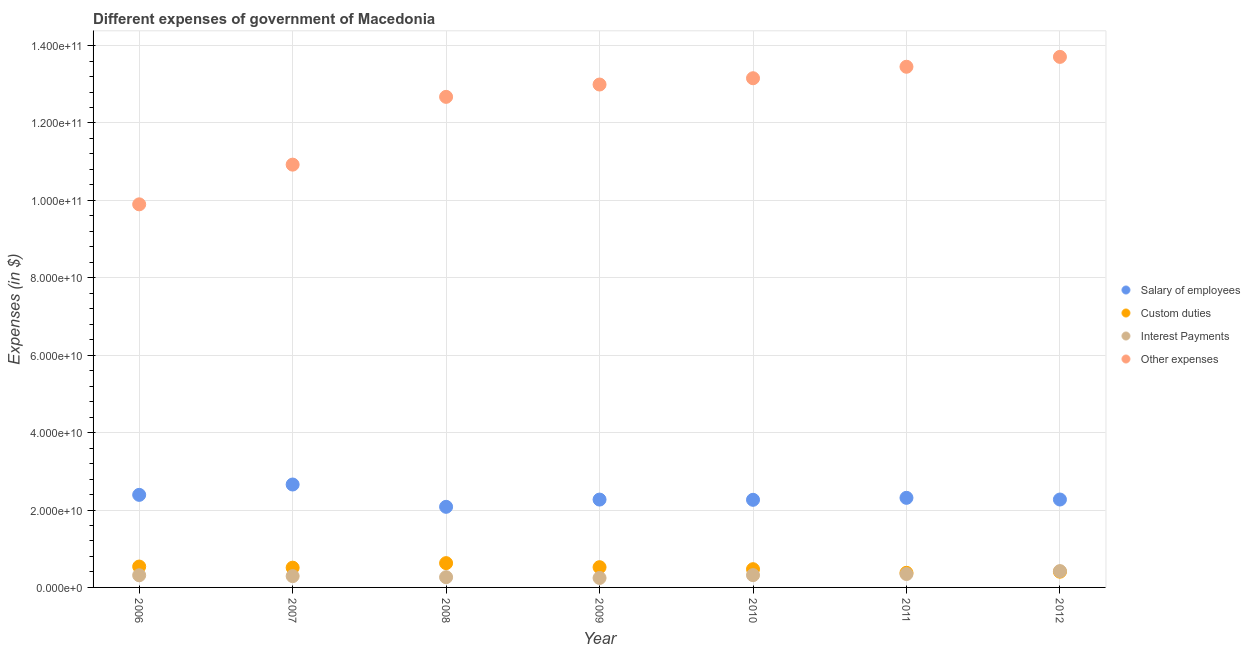How many different coloured dotlines are there?
Offer a terse response. 4. What is the amount spent on interest payments in 2008?
Your answer should be very brief. 2.65e+09. Across all years, what is the maximum amount spent on custom duties?
Your answer should be compact. 6.28e+09. Across all years, what is the minimum amount spent on custom duties?
Your response must be concise. 3.78e+09. What is the total amount spent on custom duties in the graph?
Make the answer very short. 3.46e+1. What is the difference between the amount spent on interest payments in 2010 and that in 2012?
Your answer should be compact. -1.04e+09. What is the difference between the amount spent on custom duties in 2007 and the amount spent on salary of employees in 2009?
Provide a short and direct response. -1.76e+1. What is the average amount spent on salary of employees per year?
Offer a terse response. 2.32e+1. In the year 2012, what is the difference between the amount spent on custom duties and amount spent on salary of employees?
Your answer should be compact. -1.86e+1. What is the ratio of the amount spent on interest payments in 2009 to that in 2012?
Ensure brevity in your answer.  0.58. Is the amount spent on interest payments in 2007 less than that in 2010?
Offer a terse response. Yes. Is the difference between the amount spent on custom duties in 2007 and 2011 greater than the difference between the amount spent on interest payments in 2007 and 2011?
Your answer should be very brief. Yes. What is the difference between the highest and the second highest amount spent on other expenses?
Offer a terse response. 2.55e+09. What is the difference between the highest and the lowest amount spent on salary of employees?
Offer a very short reply. 5.76e+09. Is it the case that in every year, the sum of the amount spent on salary of employees and amount spent on custom duties is greater than the amount spent on interest payments?
Make the answer very short. Yes. Is the amount spent on interest payments strictly greater than the amount spent on other expenses over the years?
Your response must be concise. No. How many years are there in the graph?
Ensure brevity in your answer.  7. Does the graph contain any zero values?
Your answer should be very brief. No. What is the title of the graph?
Offer a terse response. Different expenses of government of Macedonia. Does "Social Awareness" appear as one of the legend labels in the graph?
Your answer should be very brief. No. What is the label or title of the Y-axis?
Offer a terse response. Expenses (in $). What is the Expenses (in $) of Salary of employees in 2006?
Offer a very short reply. 2.39e+1. What is the Expenses (in $) of Custom duties in 2006?
Keep it short and to the point. 5.40e+09. What is the Expenses (in $) in Interest Payments in 2006?
Keep it short and to the point. 3.14e+09. What is the Expenses (in $) in Other expenses in 2006?
Offer a very short reply. 9.90e+1. What is the Expenses (in $) in Salary of employees in 2007?
Give a very brief answer. 2.66e+1. What is the Expenses (in $) of Custom duties in 2007?
Give a very brief answer. 5.10e+09. What is the Expenses (in $) of Interest Payments in 2007?
Ensure brevity in your answer.  2.92e+09. What is the Expenses (in $) in Other expenses in 2007?
Provide a succinct answer. 1.09e+11. What is the Expenses (in $) in Salary of employees in 2008?
Offer a very short reply. 2.08e+1. What is the Expenses (in $) of Custom duties in 2008?
Keep it short and to the point. 6.28e+09. What is the Expenses (in $) in Interest Payments in 2008?
Offer a terse response. 2.65e+09. What is the Expenses (in $) of Other expenses in 2008?
Provide a short and direct response. 1.27e+11. What is the Expenses (in $) of Salary of employees in 2009?
Offer a very short reply. 2.27e+1. What is the Expenses (in $) of Custom duties in 2009?
Ensure brevity in your answer.  5.23e+09. What is the Expenses (in $) in Interest Payments in 2009?
Provide a short and direct response. 2.44e+09. What is the Expenses (in $) of Other expenses in 2009?
Your answer should be compact. 1.30e+11. What is the Expenses (in $) of Salary of employees in 2010?
Your answer should be very brief. 2.26e+1. What is the Expenses (in $) in Custom duties in 2010?
Provide a short and direct response. 4.71e+09. What is the Expenses (in $) of Interest Payments in 2010?
Offer a very short reply. 3.17e+09. What is the Expenses (in $) of Other expenses in 2010?
Your answer should be compact. 1.32e+11. What is the Expenses (in $) in Salary of employees in 2011?
Ensure brevity in your answer.  2.31e+1. What is the Expenses (in $) in Custom duties in 2011?
Give a very brief answer. 3.78e+09. What is the Expenses (in $) in Interest Payments in 2011?
Your answer should be very brief. 3.47e+09. What is the Expenses (in $) of Other expenses in 2011?
Your answer should be very brief. 1.35e+11. What is the Expenses (in $) of Salary of employees in 2012?
Your response must be concise. 2.27e+1. What is the Expenses (in $) of Custom duties in 2012?
Your answer should be compact. 4.07e+09. What is the Expenses (in $) in Interest Payments in 2012?
Make the answer very short. 4.22e+09. What is the Expenses (in $) in Other expenses in 2012?
Give a very brief answer. 1.37e+11. Across all years, what is the maximum Expenses (in $) of Salary of employees?
Offer a terse response. 2.66e+1. Across all years, what is the maximum Expenses (in $) of Custom duties?
Keep it short and to the point. 6.28e+09. Across all years, what is the maximum Expenses (in $) of Interest Payments?
Ensure brevity in your answer.  4.22e+09. Across all years, what is the maximum Expenses (in $) in Other expenses?
Give a very brief answer. 1.37e+11. Across all years, what is the minimum Expenses (in $) in Salary of employees?
Provide a succinct answer. 2.08e+1. Across all years, what is the minimum Expenses (in $) of Custom duties?
Give a very brief answer. 3.78e+09. Across all years, what is the minimum Expenses (in $) in Interest Payments?
Your answer should be very brief. 2.44e+09. Across all years, what is the minimum Expenses (in $) in Other expenses?
Keep it short and to the point. 9.90e+1. What is the total Expenses (in $) of Salary of employees in the graph?
Provide a short and direct response. 1.63e+11. What is the total Expenses (in $) of Custom duties in the graph?
Provide a succinct answer. 3.46e+1. What is the total Expenses (in $) in Interest Payments in the graph?
Keep it short and to the point. 2.20e+1. What is the total Expenses (in $) of Other expenses in the graph?
Provide a short and direct response. 8.68e+11. What is the difference between the Expenses (in $) of Salary of employees in 2006 and that in 2007?
Offer a terse response. -2.67e+09. What is the difference between the Expenses (in $) in Custom duties in 2006 and that in 2007?
Ensure brevity in your answer.  2.94e+08. What is the difference between the Expenses (in $) in Interest Payments in 2006 and that in 2007?
Your answer should be compact. 2.22e+08. What is the difference between the Expenses (in $) of Other expenses in 2006 and that in 2007?
Your response must be concise. -1.03e+1. What is the difference between the Expenses (in $) in Salary of employees in 2006 and that in 2008?
Provide a short and direct response. 3.09e+09. What is the difference between the Expenses (in $) in Custom duties in 2006 and that in 2008?
Your response must be concise. -8.78e+08. What is the difference between the Expenses (in $) in Interest Payments in 2006 and that in 2008?
Offer a very short reply. 4.94e+08. What is the difference between the Expenses (in $) of Other expenses in 2006 and that in 2008?
Offer a very short reply. -2.78e+1. What is the difference between the Expenses (in $) of Salary of employees in 2006 and that in 2009?
Provide a succinct answer. 1.22e+09. What is the difference between the Expenses (in $) of Custom duties in 2006 and that in 2009?
Offer a terse response. 1.68e+08. What is the difference between the Expenses (in $) in Interest Payments in 2006 and that in 2009?
Make the answer very short. 6.95e+08. What is the difference between the Expenses (in $) in Other expenses in 2006 and that in 2009?
Provide a short and direct response. -3.10e+1. What is the difference between the Expenses (in $) of Salary of employees in 2006 and that in 2010?
Make the answer very short. 1.28e+09. What is the difference between the Expenses (in $) in Custom duties in 2006 and that in 2010?
Give a very brief answer. 6.85e+08. What is the difference between the Expenses (in $) of Interest Payments in 2006 and that in 2010?
Offer a terse response. -3.39e+07. What is the difference between the Expenses (in $) of Other expenses in 2006 and that in 2010?
Provide a succinct answer. -3.26e+1. What is the difference between the Expenses (in $) in Salary of employees in 2006 and that in 2011?
Keep it short and to the point. 7.71e+08. What is the difference between the Expenses (in $) in Custom duties in 2006 and that in 2011?
Provide a succinct answer. 1.62e+09. What is the difference between the Expenses (in $) of Interest Payments in 2006 and that in 2011?
Provide a succinct answer. -3.31e+08. What is the difference between the Expenses (in $) in Other expenses in 2006 and that in 2011?
Your answer should be very brief. -3.55e+1. What is the difference between the Expenses (in $) of Salary of employees in 2006 and that in 2012?
Ensure brevity in your answer.  1.20e+09. What is the difference between the Expenses (in $) of Custom duties in 2006 and that in 2012?
Your response must be concise. 1.33e+09. What is the difference between the Expenses (in $) of Interest Payments in 2006 and that in 2012?
Offer a very short reply. -1.08e+09. What is the difference between the Expenses (in $) of Other expenses in 2006 and that in 2012?
Your answer should be compact. -3.81e+1. What is the difference between the Expenses (in $) in Salary of employees in 2007 and that in 2008?
Your response must be concise. 5.76e+09. What is the difference between the Expenses (in $) in Custom duties in 2007 and that in 2008?
Offer a very short reply. -1.17e+09. What is the difference between the Expenses (in $) in Interest Payments in 2007 and that in 2008?
Your answer should be very brief. 2.72e+08. What is the difference between the Expenses (in $) of Other expenses in 2007 and that in 2008?
Ensure brevity in your answer.  -1.75e+1. What is the difference between the Expenses (in $) in Salary of employees in 2007 and that in 2009?
Make the answer very short. 3.89e+09. What is the difference between the Expenses (in $) of Custom duties in 2007 and that in 2009?
Provide a succinct answer. -1.26e+08. What is the difference between the Expenses (in $) in Interest Payments in 2007 and that in 2009?
Provide a short and direct response. 4.73e+08. What is the difference between the Expenses (in $) in Other expenses in 2007 and that in 2009?
Offer a terse response. -2.07e+1. What is the difference between the Expenses (in $) of Salary of employees in 2007 and that in 2010?
Provide a succinct answer. 3.95e+09. What is the difference between the Expenses (in $) of Custom duties in 2007 and that in 2010?
Make the answer very short. 3.91e+08. What is the difference between the Expenses (in $) of Interest Payments in 2007 and that in 2010?
Make the answer very short. -2.56e+08. What is the difference between the Expenses (in $) of Other expenses in 2007 and that in 2010?
Keep it short and to the point. -2.23e+1. What is the difference between the Expenses (in $) of Salary of employees in 2007 and that in 2011?
Provide a succinct answer. 3.44e+09. What is the difference between the Expenses (in $) in Custom duties in 2007 and that in 2011?
Your answer should be compact. 1.32e+09. What is the difference between the Expenses (in $) of Interest Payments in 2007 and that in 2011?
Make the answer very short. -5.53e+08. What is the difference between the Expenses (in $) of Other expenses in 2007 and that in 2011?
Give a very brief answer. -2.53e+1. What is the difference between the Expenses (in $) of Salary of employees in 2007 and that in 2012?
Ensure brevity in your answer.  3.88e+09. What is the difference between the Expenses (in $) in Custom duties in 2007 and that in 2012?
Your response must be concise. 1.04e+09. What is the difference between the Expenses (in $) in Interest Payments in 2007 and that in 2012?
Offer a terse response. -1.30e+09. What is the difference between the Expenses (in $) in Other expenses in 2007 and that in 2012?
Make the answer very short. -2.78e+1. What is the difference between the Expenses (in $) in Salary of employees in 2008 and that in 2009?
Your answer should be compact. -1.87e+09. What is the difference between the Expenses (in $) of Custom duties in 2008 and that in 2009?
Ensure brevity in your answer.  1.05e+09. What is the difference between the Expenses (in $) of Interest Payments in 2008 and that in 2009?
Offer a terse response. 2.01e+08. What is the difference between the Expenses (in $) of Other expenses in 2008 and that in 2009?
Keep it short and to the point. -3.19e+09. What is the difference between the Expenses (in $) of Salary of employees in 2008 and that in 2010?
Make the answer very short. -1.81e+09. What is the difference between the Expenses (in $) in Custom duties in 2008 and that in 2010?
Keep it short and to the point. 1.56e+09. What is the difference between the Expenses (in $) of Interest Payments in 2008 and that in 2010?
Make the answer very short. -5.28e+08. What is the difference between the Expenses (in $) of Other expenses in 2008 and that in 2010?
Ensure brevity in your answer.  -4.81e+09. What is the difference between the Expenses (in $) of Salary of employees in 2008 and that in 2011?
Keep it short and to the point. -2.32e+09. What is the difference between the Expenses (in $) of Custom duties in 2008 and that in 2011?
Give a very brief answer. 2.50e+09. What is the difference between the Expenses (in $) in Interest Payments in 2008 and that in 2011?
Offer a very short reply. -8.25e+08. What is the difference between the Expenses (in $) in Other expenses in 2008 and that in 2011?
Provide a succinct answer. -7.78e+09. What is the difference between the Expenses (in $) in Salary of employees in 2008 and that in 2012?
Ensure brevity in your answer.  -1.89e+09. What is the difference between the Expenses (in $) of Custom duties in 2008 and that in 2012?
Provide a short and direct response. 2.21e+09. What is the difference between the Expenses (in $) of Interest Payments in 2008 and that in 2012?
Your answer should be very brief. -1.57e+09. What is the difference between the Expenses (in $) in Other expenses in 2008 and that in 2012?
Your response must be concise. -1.03e+1. What is the difference between the Expenses (in $) in Salary of employees in 2009 and that in 2010?
Provide a short and direct response. 6.10e+07. What is the difference between the Expenses (in $) in Custom duties in 2009 and that in 2010?
Your response must be concise. 5.17e+08. What is the difference between the Expenses (in $) of Interest Payments in 2009 and that in 2010?
Keep it short and to the point. -7.29e+08. What is the difference between the Expenses (in $) in Other expenses in 2009 and that in 2010?
Ensure brevity in your answer.  -1.62e+09. What is the difference between the Expenses (in $) in Salary of employees in 2009 and that in 2011?
Make the answer very short. -4.48e+08. What is the difference between the Expenses (in $) in Custom duties in 2009 and that in 2011?
Ensure brevity in your answer.  1.45e+09. What is the difference between the Expenses (in $) in Interest Payments in 2009 and that in 2011?
Provide a succinct answer. -1.03e+09. What is the difference between the Expenses (in $) in Other expenses in 2009 and that in 2011?
Your answer should be very brief. -4.59e+09. What is the difference between the Expenses (in $) of Salary of employees in 2009 and that in 2012?
Provide a succinct answer. -1.50e+07. What is the difference between the Expenses (in $) of Custom duties in 2009 and that in 2012?
Keep it short and to the point. 1.16e+09. What is the difference between the Expenses (in $) of Interest Payments in 2009 and that in 2012?
Your response must be concise. -1.77e+09. What is the difference between the Expenses (in $) of Other expenses in 2009 and that in 2012?
Your answer should be very brief. -7.14e+09. What is the difference between the Expenses (in $) of Salary of employees in 2010 and that in 2011?
Offer a terse response. -5.09e+08. What is the difference between the Expenses (in $) in Custom duties in 2010 and that in 2011?
Ensure brevity in your answer.  9.33e+08. What is the difference between the Expenses (in $) of Interest Payments in 2010 and that in 2011?
Offer a very short reply. -2.97e+08. What is the difference between the Expenses (in $) in Other expenses in 2010 and that in 2011?
Keep it short and to the point. -2.96e+09. What is the difference between the Expenses (in $) of Salary of employees in 2010 and that in 2012?
Your answer should be very brief. -7.60e+07. What is the difference between the Expenses (in $) in Custom duties in 2010 and that in 2012?
Your answer should be very brief. 6.45e+08. What is the difference between the Expenses (in $) of Interest Payments in 2010 and that in 2012?
Provide a succinct answer. -1.04e+09. What is the difference between the Expenses (in $) in Other expenses in 2010 and that in 2012?
Ensure brevity in your answer.  -5.52e+09. What is the difference between the Expenses (in $) of Salary of employees in 2011 and that in 2012?
Keep it short and to the point. 4.33e+08. What is the difference between the Expenses (in $) of Custom duties in 2011 and that in 2012?
Offer a terse response. -2.88e+08. What is the difference between the Expenses (in $) in Interest Payments in 2011 and that in 2012?
Your answer should be compact. -7.45e+08. What is the difference between the Expenses (in $) in Other expenses in 2011 and that in 2012?
Offer a very short reply. -2.55e+09. What is the difference between the Expenses (in $) in Salary of employees in 2006 and the Expenses (in $) in Custom duties in 2007?
Make the answer very short. 1.88e+1. What is the difference between the Expenses (in $) in Salary of employees in 2006 and the Expenses (in $) in Interest Payments in 2007?
Give a very brief answer. 2.10e+1. What is the difference between the Expenses (in $) in Salary of employees in 2006 and the Expenses (in $) in Other expenses in 2007?
Offer a terse response. -8.53e+1. What is the difference between the Expenses (in $) of Custom duties in 2006 and the Expenses (in $) of Interest Payments in 2007?
Offer a very short reply. 2.48e+09. What is the difference between the Expenses (in $) of Custom duties in 2006 and the Expenses (in $) of Other expenses in 2007?
Offer a very short reply. -1.04e+11. What is the difference between the Expenses (in $) in Interest Payments in 2006 and the Expenses (in $) in Other expenses in 2007?
Provide a succinct answer. -1.06e+11. What is the difference between the Expenses (in $) of Salary of employees in 2006 and the Expenses (in $) of Custom duties in 2008?
Your response must be concise. 1.76e+1. What is the difference between the Expenses (in $) of Salary of employees in 2006 and the Expenses (in $) of Interest Payments in 2008?
Offer a terse response. 2.13e+1. What is the difference between the Expenses (in $) of Salary of employees in 2006 and the Expenses (in $) of Other expenses in 2008?
Your response must be concise. -1.03e+11. What is the difference between the Expenses (in $) of Custom duties in 2006 and the Expenses (in $) of Interest Payments in 2008?
Offer a terse response. 2.75e+09. What is the difference between the Expenses (in $) of Custom duties in 2006 and the Expenses (in $) of Other expenses in 2008?
Ensure brevity in your answer.  -1.21e+11. What is the difference between the Expenses (in $) in Interest Payments in 2006 and the Expenses (in $) in Other expenses in 2008?
Provide a succinct answer. -1.24e+11. What is the difference between the Expenses (in $) in Salary of employees in 2006 and the Expenses (in $) in Custom duties in 2009?
Offer a terse response. 1.87e+1. What is the difference between the Expenses (in $) of Salary of employees in 2006 and the Expenses (in $) of Interest Payments in 2009?
Your answer should be very brief. 2.15e+1. What is the difference between the Expenses (in $) of Salary of employees in 2006 and the Expenses (in $) of Other expenses in 2009?
Keep it short and to the point. -1.06e+11. What is the difference between the Expenses (in $) in Custom duties in 2006 and the Expenses (in $) in Interest Payments in 2009?
Provide a short and direct response. 2.95e+09. What is the difference between the Expenses (in $) of Custom duties in 2006 and the Expenses (in $) of Other expenses in 2009?
Provide a succinct answer. -1.25e+11. What is the difference between the Expenses (in $) of Interest Payments in 2006 and the Expenses (in $) of Other expenses in 2009?
Provide a short and direct response. -1.27e+11. What is the difference between the Expenses (in $) in Salary of employees in 2006 and the Expenses (in $) in Custom duties in 2010?
Keep it short and to the point. 1.92e+1. What is the difference between the Expenses (in $) in Salary of employees in 2006 and the Expenses (in $) in Interest Payments in 2010?
Ensure brevity in your answer.  2.07e+1. What is the difference between the Expenses (in $) in Salary of employees in 2006 and the Expenses (in $) in Other expenses in 2010?
Offer a very short reply. -1.08e+11. What is the difference between the Expenses (in $) in Custom duties in 2006 and the Expenses (in $) in Interest Payments in 2010?
Your answer should be very brief. 2.22e+09. What is the difference between the Expenses (in $) of Custom duties in 2006 and the Expenses (in $) of Other expenses in 2010?
Provide a short and direct response. -1.26e+11. What is the difference between the Expenses (in $) of Interest Payments in 2006 and the Expenses (in $) of Other expenses in 2010?
Ensure brevity in your answer.  -1.28e+11. What is the difference between the Expenses (in $) in Salary of employees in 2006 and the Expenses (in $) in Custom duties in 2011?
Give a very brief answer. 2.01e+1. What is the difference between the Expenses (in $) of Salary of employees in 2006 and the Expenses (in $) of Interest Payments in 2011?
Provide a succinct answer. 2.04e+1. What is the difference between the Expenses (in $) of Salary of employees in 2006 and the Expenses (in $) of Other expenses in 2011?
Keep it short and to the point. -1.11e+11. What is the difference between the Expenses (in $) in Custom duties in 2006 and the Expenses (in $) in Interest Payments in 2011?
Keep it short and to the point. 1.93e+09. What is the difference between the Expenses (in $) in Custom duties in 2006 and the Expenses (in $) in Other expenses in 2011?
Ensure brevity in your answer.  -1.29e+11. What is the difference between the Expenses (in $) of Interest Payments in 2006 and the Expenses (in $) of Other expenses in 2011?
Offer a terse response. -1.31e+11. What is the difference between the Expenses (in $) in Salary of employees in 2006 and the Expenses (in $) in Custom duties in 2012?
Your response must be concise. 1.99e+1. What is the difference between the Expenses (in $) of Salary of employees in 2006 and the Expenses (in $) of Interest Payments in 2012?
Offer a terse response. 1.97e+1. What is the difference between the Expenses (in $) in Salary of employees in 2006 and the Expenses (in $) in Other expenses in 2012?
Your answer should be compact. -1.13e+11. What is the difference between the Expenses (in $) in Custom duties in 2006 and the Expenses (in $) in Interest Payments in 2012?
Your answer should be very brief. 1.18e+09. What is the difference between the Expenses (in $) in Custom duties in 2006 and the Expenses (in $) in Other expenses in 2012?
Your answer should be very brief. -1.32e+11. What is the difference between the Expenses (in $) of Interest Payments in 2006 and the Expenses (in $) of Other expenses in 2012?
Offer a very short reply. -1.34e+11. What is the difference between the Expenses (in $) of Salary of employees in 2007 and the Expenses (in $) of Custom duties in 2008?
Offer a terse response. 2.03e+1. What is the difference between the Expenses (in $) of Salary of employees in 2007 and the Expenses (in $) of Interest Payments in 2008?
Provide a short and direct response. 2.39e+1. What is the difference between the Expenses (in $) in Salary of employees in 2007 and the Expenses (in $) in Other expenses in 2008?
Keep it short and to the point. -1.00e+11. What is the difference between the Expenses (in $) of Custom duties in 2007 and the Expenses (in $) of Interest Payments in 2008?
Provide a succinct answer. 2.46e+09. What is the difference between the Expenses (in $) in Custom duties in 2007 and the Expenses (in $) in Other expenses in 2008?
Your answer should be compact. -1.22e+11. What is the difference between the Expenses (in $) in Interest Payments in 2007 and the Expenses (in $) in Other expenses in 2008?
Give a very brief answer. -1.24e+11. What is the difference between the Expenses (in $) of Salary of employees in 2007 and the Expenses (in $) of Custom duties in 2009?
Provide a succinct answer. 2.14e+1. What is the difference between the Expenses (in $) in Salary of employees in 2007 and the Expenses (in $) in Interest Payments in 2009?
Provide a short and direct response. 2.41e+1. What is the difference between the Expenses (in $) of Salary of employees in 2007 and the Expenses (in $) of Other expenses in 2009?
Give a very brief answer. -1.03e+11. What is the difference between the Expenses (in $) of Custom duties in 2007 and the Expenses (in $) of Interest Payments in 2009?
Make the answer very short. 2.66e+09. What is the difference between the Expenses (in $) in Custom duties in 2007 and the Expenses (in $) in Other expenses in 2009?
Ensure brevity in your answer.  -1.25e+11. What is the difference between the Expenses (in $) of Interest Payments in 2007 and the Expenses (in $) of Other expenses in 2009?
Your answer should be compact. -1.27e+11. What is the difference between the Expenses (in $) in Salary of employees in 2007 and the Expenses (in $) in Custom duties in 2010?
Your answer should be very brief. 2.19e+1. What is the difference between the Expenses (in $) of Salary of employees in 2007 and the Expenses (in $) of Interest Payments in 2010?
Offer a very short reply. 2.34e+1. What is the difference between the Expenses (in $) of Salary of employees in 2007 and the Expenses (in $) of Other expenses in 2010?
Your answer should be very brief. -1.05e+11. What is the difference between the Expenses (in $) of Custom duties in 2007 and the Expenses (in $) of Interest Payments in 2010?
Your answer should be compact. 1.93e+09. What is the difference between the Expenses (in $) of Custom duties in 2007 and the Expenses (in $) of Other expenses in 2010?
Offer a terse response. -1.26e+11. What is the difference between the Expenses (in $) of Interest Payments in 2007 and the Expenses (in $) of Other expenses in 2010?
Your response must be concise. -1.29e+11. What is the difference between the Expenses (in $) of Salary of employees in 2007 and the Expenses (in $) of Custom duties in 2011?
Your answer should be compact. 2.28e+1. What is the difference between the Expenses (in $) in Salary of employees in 2007 and the Expenses (in $) in Interest Payments in 2011?
Ensure brevity in your answer.  2.31e+1. What is the difference between the Expenses (in $) of Salary of employees in 2007 and the Expenses (in $) of Other expenses in 2011?
Your response must be concise. -1.08e+11. What is the difference between the Expenses (in $) in Custom duties in 2007 and the Expenses (in $) in Interest Payments in 2011?
Make the answer very short. 1.63e+09. What is the difference between the Expenses (in $) of Custom duties in 2007 and the Expenses (in $) of Other expenses in 2011?
Offer a terse response. -1.29e+11. What is the difference between the Expenses (in $) in Interest Payments in 2007 and the Expenses (in $) in Other expenses in 2011?
Your response must be concise. -1.32e+11. What is the difference between the Expenses (in $) of Salary of employees in 2007 and the Expenses (in $) of Custom duties in 2012?
Offer a terse response. 2.25e+1. What is the difference between the Expenses (in $) in Salary of employees in 2007 and the Expenses (in $) in Interest Payments in 2012?
Keep it short and to the point. 2.24e+1. What is the difference between the Expenses (in $) in Salary of employees in 2007 and the Expenses (in $) in Other expenses in 2012?
Make the answer very short. -1.10e+11. What is the difference between the Expenses (in $) in Custom duties in 2007 and the Expenses (in $) in Interest Payments in 2012?
Ensure brevity in your answer.  8.87e+08. What is the difference between the Expenses (in $) of Custom duties in 2007 and the Expenses (in $) of Other expenses in 2012?
Ensure brevity in your answer.  -1.32e+11. What is the difference between the Expenses (in $) in Interest Payments in 2007 and the Expenses (in $) in Other expenses in 2012?
Provide a succinct answer. -1.34e+11. What is the difference between the Expenses (in $) in Salary of employees in 2008 and the Expenses (in $) in Custom duties in 2009?
Keep it short and to the point. 1.56e+1. What is the difference between the Expenses (in $) of Salary of employees in 2008 and the Expenses (in $) of Interest Payments in 2009?
Your answer should be compact. 1.84e+1. What is the difference between the Expenses (in $) in Salary of employees in 2008 and the Expenses (in $) in Other expenses in 2009?
Your answer should be compact. -1.09e+11. What is the difference between the Expenses (in $) in Custom duties in 2008 and the Expenses (in $) in Interest Payments in 2009?
Provide a succinct answer. 3.83e+09. What is the difference between the Expenses (in $) of Custom duties in 2008 and the Expenses (in $) of Other expenses in 2009?
Offer a terse response. -1.24e+11. What is the difference between the Expenses (in $) in Interest Payments in 2008 and the Expenses (in $) in Other expenses in 2009?
Offer a very short reply. -1.27e+11. What is the difference between the Expenses (in $) of Salary of employees in 2008 and the Expenses (in $) of Custom duties in 2010?
Provide a short and direct response. 1.61e+1. What is the difference between the Expenses (in $) in Salary of employees in 2008 and the Expenses (in $) in Interest Payments in 2010?
Your answer should be very brief. 1.77e+1. What is the difference between the Expenses (in $) of Salary of employees in 2008 and the Expenses (in $) of Other expenses in 2010?
Your answer should be compact. -1.11e+11. What is the difference between the Expenses (in $) in Custom duties in 2008 and the Expenses (in $) in Interest Payments in 2010?
Provide a succinct answer. 3.10e+09. What is the difference between the Expenses (in $) in Custom duties in 2008 and the Expenses (in $) in Other expenses in 2010?
Give a very brief answer. -1.25e+11. What is the difference between the Expenses (in $) in Interest Payments in 2008 and the Expenses (in $) in Other expenses in 2010?
Make the answer very short. -1.29e+11. What is the difference between the Expenses (in $) in Salary of employees in 2008 and the Expenses (in $) in Custom duties in 2011?
Ensure brevity in your answer.  1.70e+1. What is the difference between the Expenses (in $) of Salary of employees in 2008 and the Expenses (in $) of Interest Payments in 2011?
Keep it short and to the point. 1.74e+1. What is the difference between the Expenses (in $) of Salary of employees in 2008 and the Expenses (in $) of Other expenses in 2011?
Your response must be concise. -1.14e+11. What is the difference between the Expenses (in $) of Custom duties in 2008 and the Expenses (in $) of Interest Payments in 2011?
Your answer should be very brief. 2.80e+09. What is the difference between the Expenses (in $) of Custom duties in 2008 and the Expenses (in $) of Other expenses in 2011?
Offer a very short reply. -1.28e+11. What is the difference between the Expenses (in $) in Interest Payments in 2008 and the Expenses (in $) in Other expenses in 2011?
Make the answer very short. -1.32e+11. What is the difference between the Expenses (in $) of Salary of employees in 2008 and the Expenses (in $) of Custom duties in 2012?
Keep it short and to the point. 1.68e+1. What is the difference between the Expenses (in $) of Salary of employees in 2008 and the Expenses (in $) of Interest Payments in 2012?
Provide a short and direct response. 1.66e+1. What is the difference between the Expenses (in $) in Salary of employees in 2008 and the Expenses (in $) in Other expenses in 2012?
Ensure brevity in your answer.  -1.16e+11. What is the difference between the Expenses (in $) in Custom duties in 2008 and the Expenses (in $) in Interest Payments in 2012?
Offer a very short reply. 2.06e+09. What is the difference between the Expenses (in $) in Custom duties in 2008 and the Expenses (in $) in Other expenses in 2012?
Your response must be concise. -1.31e+11. What is the difference between the Expenses (in $) in Interest Payments in 2008 and the Expenses (in $) in Other expenses in 2012?
Offer a very short reply. -1.34e+11. What is the difference between the Expenses (in $) of Salary of employees in 2009 and the Expenses (in $) of Custom duties in 2010?
Provide a succinct answer. 1.80e+1. What is the difference between the Expenses (in $) of Salary of employees in 2009 and the Expenses (in $) of Interest Payments in 2010?
Your response must be concise. 1.95e+1. What is the difference between the Expenses (in $) of Salary of employees in 2009 and the Expenses (in $) of Other expenses in 2010?
Provide a short and direct response. -1.09e+11. What is the difference between the Expenses (in $) in Custom duties in 2009 and the Expenses (in $) in Interest Payments in 2010?
Make the answer very short. 2.06e+09. What is the difference between the Expenses (in $) of Custom duties in 2009 and the Expenses (in $) of Other expenses in 2010?
Make the answer very short. -1.26e+11. What is the difference between the Expenses (in $) of Interest Payments in 2009 and the Expenses (in $) of Other expenses in 2010?
Provide a short and direct response. -1.29e+11. What is the difference between the Expenses (in $) in Salary of employees in 2009 and the Expenses (in $) in Custom duties in 2011?
Your answer should be compact. 1.89e+1. What is the difference between the Expenses (in $) in Salary of employees in 2009 and the Expenses (in $) in Interest Payments in 2011?
Offer a very short reply. 1.92e+1. What is the difference between the Expenses (in $) of Salary of employees in 2009 and the Expenses (in $) of Other expenses in 2011?
Keep it short and to the point. -1.12e+11. What is the difference between the Expenses (in $) in Custom duties in 2009 and the Expenses (in $) in Interest Payments in 2011?
Your answer should be very brief. 1.76e+09. What is the difference between the Expenses (in $) in Custom duties in 2009 and the Expenses (in $) in Other expenses in 2011?
Offer a very short reply. -1.29e+11. What is the difference between the Expenses (in $) in Interest Payments in 2009 and the Expenses (in $) in Other expenses in 2011?
Your response must be concise. -1.32e+11. What is the difference between the Expenses (in $) of Salary of employees in 2009 and the Expenses (in $) of Custom duties in 2012?
Provide a succinct answer. 1.86e+1. What is the difference between the Expenses (in $) of Salary of employees in 2009 and the Expenses (in $) of Interest Payments in 2012?
Provide a short and direct response. 1.85e+1. What is the difference between the Expenses (in $) of Salary of employees in 2009 and the Expenses (in $) of Other expenses in 2012?
Keep it short and to the point. -1.14e+11. What is the difference between the Expenses (in $) of Custom duties in 2009 and the Expenses (in $) of Interest Payments in 2012?
Your answer should be very brief. 1.01e+09. What is the difference between the Expenses (in $) of Custom duties in 2009 and the Expenses (in $) of Other expenses in 2012?
Provide a short and direct response. -1.32e+11. What is the difference between the Expenses (in $) in Interest Payments in 2009 and the Expenses (in $) in Other expenses in 2012?
Provide a succinct answer. -1.35e+11. What is the difference between the Expenses (in $) in Salary of employees in 2010 and the Expenses (in $) in Custom duties in 2011?
Keep it short and to the point. 1.89e+1. What is the difference between the Expenses (in $) of Salary of employees in 2010 and the Expenses (in $) of Interest Payments in 2011?
Provide a succinct answer. 1.92e+1. What is the difference between the Expenses (in $) of Salary of employees in 2010 and the Expenses (in $) of Other expenses in 2011?
Your answer should be compact. -1.12e+11. What is the difference between the Expenses (in $) of Custom duties in 2010 and the Expenses (in $) of Interest Payments in 2011?
Offer a terse response. 1.24e+09. What is the difference between the Expenses (in $) in Custom duties in 2010 and the Expenses (in $) in Other expenses in 2011?
Ensure brevity in your answer.  -1.30e+11. What is the difference between the Expenses (in $) of Interest Payments in 2010 and the Expenses (in $) of Other expenses in 2011?
Keep it short and to the point. -1.31e+11. What is the difference between the Expenses (in $) of Salary of employees in 2010 and the Expenses (in $) of Custom duties in 2012?
Keep it short and to the point. 1.86e+1. What is the difference between the Expenses (in $) in Salary of employees in 2010 and the Expenses (in $) in Interest Payments in 2012?
Keep it short and to the point. 1.84e+1. What is the difference between the Expenses (in $) in Salary of employees in 2010 and the Expenses (in $) in Other expenses in 2012?
Your response must be concise. -1.14e+11. What is the difference between the Expenses (in $) of Custom duties in 2010 and the Expenses (in $) of Interest Payments in 2012?
Offer a terse response. 4.96e+08. What is the difference between the Expenses (in $) of Custom duties in 2010 and the Expenses (in $) of Other expenses in 2012?
Provide a short and direct response. -1.32e+11. What is the difference between the Expenses (in $) of Interest Payments in 2010 and the Expenses (in $) of Other expenses in 2012?
Your answer should be very brief. -1.34e+11. What is the difference between the Expenses (in $) of Salary of employees in 2011 and the Expenses (in $) of Custom duties in 2012?
Keep it short and to the point. 1.91e+1. What is the difference between the Expenses (in $) of Salary of employees in 2011 and the Expenses (in $) of Interest Payments in 2012?
Offer a very short reply. 1.89e+1. What is the difference between the Expenses (in $) in Salary of employees in 2011 and the Expenses (in $) in Other expenses in 2012?
Offer a terse response. -1.14e+11. What is the difference between the Expenses (in $) in Custom duties in 2011 and the Expenses (in $) in Interest Payments in 2012?
Make the answer very short. -4.37e+08. What is the difference between the Expenses (in $) of Custom duties in 2011 and the Expenses (in $) of Other expenses in 2012?
Your answer should be compact. -1.33e+11. What is the difference between the Expenses (in $) in Interest Payments in 2011 and the Expenses (in $) in Other expenses in 2012?
Keep it short and to the point. -1.34e+11. What is the average Expenses (in $) in Salary of employees per year?
Give a very brief answer. 2.32e+1. What is the average Expenses (in $) of Custom duties per year?
Your response must be concise. 4.94e+09. What is the average Expenses (in $) in Interest Payments per year?
Provide a short and direct response. 3.14e+09. What is the average Expenses (in $) of Other expenses per year?
Keep it short and to the point. 1.24e+11. In the year 2006, what is the difference between the Expenses (in $) of Salary of employees and Expenses (in $) of Custom duties?
Make the answer very short. 1.85e+1. In the year 2006, what is the difference between the Expenses (in $) of Salary of employees and Expenses (in $) of Interest Payments?
Provide a short and direct response. 2.08e+1. In the year 2006, what is the difference between the Expenses (in $) of Salary of employees and Expenses (in $) of Other expenses?
Provide a succinct answer. -7.51e+1. In the year 2006, what is the difference between the Expenses (in $) in Custom duties and Expenses (in $) in Interest Payments?
Ensure brevity in your answer.  2.26e+09. In the year 2006, what is the difference between the Expenses (in $) in Custom duties and Expenses (in $) in Other expenses?
Make the answer very short. -9.36e+1. In the year 2006, what is the difference between the Expenses (in $) in Interest Payments and Expenses (in $) in Other expenses?
Offer a terse response. -9.58e+1. In the year 2007, what is the difference between the Expenses (in $) in Salary of employees and Expenses (in $) in Custom duties?
Ensure brevity in your answer.  2.15e+1. In the year 2007, what is the difference between the Expenses (in $) in Salary of employees and Expenses (in $) in Interest Payments?
Provide a short and direct response. 2.37e+1. In the year 2007, what is the difference between the Expenses (in $) of Salary of employees and Expenses (in $) of Other expenses?
Offer a terse response. -8.26e+1. In the year 2007, what is the difference between the Expenses (in $) of Custom duties and Expenses (in $) of Interest Payments?
Your answer should be compact. 2.18e+09. In the year 2007, what is the difference between the Expenses (in $) in Custom duties and Expenses (in $) in Other expenses?
Your response must be concise. -1.04e+11. In the year 2007, what is the difference between the Expenses (in $) in Interest Payments and Expenses (in $) in Other expenses?
Keep it short and to the point. -1.06e+11. In the year 2008, what is the difference between the Expenses (in $) of Salary of employees and Expenses (in $) of Custom duties?
Provide a short and direct response. 1.46e+1. In the year 2008, what is the difference between the Expenses (in $) in Salary of employees and Expenses (in $) in Interest Payments?
Ensure brevity in your answer.  1.82e+1. In the year 2008, what is the difference between the Expenses (in $) of Salary of employees and Expenses (in $) of Other expenses?
Offer a terse response. -1.06e+11. In the year 2008, what is the difference between the Expenses (in $) of Custom duties and Expenses (in $) of Interest Payments?
Your answer should be very brief. 3.63e+09. In the year 2008, what is the difference between the Expenses (in $) of Custom duties and Expenses (in $) of Other expenses?
Offer a terse response. -1.20e+11. In the year 2008, what is the difference between the Expenses (in $) of Interest Payments and Expenses (in $) of Other expenses?
Provide a short and direct response. -1.24e+11. In the year 2009, what is the difference between the Expenses (in $) in Salary of employees and Expenses (in $) in Custom duties?
Give a very brief answer. 1.75e+1. In the year 2009, what is the difference between the Expenses (in $) of Salary of employees and Expenses (in $) of Interest Payments?
Keep it short and to the point. 2.03e+1. In the year 2009, what is the difference between the Expenses (in $) of Salary of employees and Expenses (in $) of Other expenses?
Make the answer very short. -1.07e+11. In the year 2009, what is the difference between the Expenses (in $) of Custom duties and Expenses (in $) of Interest Payments?
Ensure brevity in your answer.  2.78e+09. In the year 2009, what is the difference between the Expenses (in $) of Custom duties and Expenses (in $) of Other expenses?
Offer a very short reply. -1.25e+11. In the year 2009, what is the difference between the Expenses (in $) in Interest Payments and Expenses (in $) in Other expenses?
Your answer should be very brief. -1.27e+11. In the year 2010, what is the difference between the Expenses (in $) in Salary of employees and Expenses (in $) in Custom duties?
Give a very brief answer. 1.79e+1. In the year 2010, what is the difference between the Expenses (in $) in Salary of employees and Expenses (in $) in Interest Payments?
Ensure brevity in your answer.  1.95e+1. In the year 2010, what is the difference between the Expenses (in $) in Salary of employees and Expenses (in $) in Other expenses?
Make the answer very short. -1.09e+11. In the year 2010, what is the difference between the Expenses (in $) in Custom duties and Expenses (in $) in Interest Payments?
Offer a terse response. 1.54e+09. In the year 2010, what is the difference between the Expenses (in $) in Custom duties and Expenses (in $) in Other expenses?
Ensure brevity in your answer.  -1.27e+11. In the year 2010, what is the difference between the Expenses (in $) of Interest Payments and Expenses (in $) of Other expenses?
Offer a terse response. -1.28e+11. In the year 2011, what is the difference between the Expenses (in $) in Salary of employees and Expenses (in $) in Custom duties?
Keep it short and to the point. 1.94e+1. In the year 2011, what is the difference between the Expenses (in $) of Salary of employees and Expenses (in $) of Interest Payments?
Make the answer very short. 1.97e+1. In the year 2011, what is the difference between the Expenses (in $) of Salary of employees and Expenses (in $) of Other expenses?
Keep it short and to the point. -1.11e+11. In the year 2011, what is the difference between the Expenses (in $) of Custom duties and Expenses (in $) of Interest Payments?
Your response must be concise. 3.08e+08. In the year 2011, what is the difference between the Expenses (in $) in Custom duties and Expenses (in $) in Other expenses?
Your answer should be very brief. -1.31e+11. In the year 2011, what is the difference between the Expenses (in $) in Interest Payments and Expenses (in $) in Other expenses?
Make the answer very short. -1.31e+11. In the year 2012, what is the difference between the Expenses (in $) of Salary of employees and Expenses (in $) of Custom duties?
Make the answer very short. 1.86e+1. In the year 2012, what is the difference between the Expenses (in $) of Salary of employees and Expenses (in $) of Interest Payments?
Provide a short and direct response. 1.85e+1. In the year 2012, what is the difference between the Expenses (in $) in Salary of employees and Expenses (in $) in Other expenses?
Give a very brief answer. -1.14e+11. In the year 2012, what is the difference between the Expenses (in $) of Custom duties and Expenses (in $) of Interest Payments?
Your response must be concise. -1.49e+08. In the year 2012, what is the difference between the Expenses (in $) in Custom duties and Expenses (in $) in Other expenses?
Make the answer very short. -1.33e+11. In the year 2012, what is the difference between the Expenses (in $) of Interest Payments and Expenses (in $) of Other expenses?
Give a very brief answer. -1.33e+11. What is the ratio of the Expenses (in $) in Salary of employees in 2006 to that in 2007?
Offer a very short reply. 0.9. What is the ratio of the Expenses (in $) in Custom duties in 2006 to that in 2007?
Ensure brevity in your answer.  1.06. What is the ratio of the Expenses (in $) of Interest Payments in 2006 to that in 2007?
Ensure brevity in your answer.  1.08. What is the ratio of the Expenses (in $) in Other expenses in 2006 to that in 2007?
Provide a succinct answer. 0.91. What is the ratio of the Expenses (in $) of Salary of employees in 2006 to that in 2008?
Keep it short and to the point. 1.15. What is the ratio of the Expenses (in $) of Custom duties in 2006 to that in 2008?
Ensure brevity in your answer.  0.86. What is the ratio of the Expenses (in $) of Interest Payments in 2006 to that in 2008?
Your response must be concise. 1.19. What is the ratio of the Expenses (in $) of Other expenses in 2006 to that in 2008?
Give a very brief answer. 0.78. What is the ratio of the Expenses (in $) in Salary of employees in 2006 to that in 2009?
Ensure brevity in your answer.  1.05. What is the ratio of the Expenses (in $) of Custom duties in 2006 to that in 2009?
Ensure brevity in your answer.  1.03. What is the ratio of the Expenses (in $) in Interest Payments in 2006 to that in 2009?
Offer a very short reply. 1.28. What is the ratio of the Expenses (in $) in Other expenses in 2006 to that in 2009?
Keep it short and to the point. 0.76. What is the ratio of the Expenses (in $) in Salary of employees in 2006 to that in 2010?
Offer a very short reply. 1.06. What is the ratio of the Expenses (in $) in Custom duties in 2006 to that in 2010?
Offer a terse response. 1.15. What is the ratio of the Expenses (in $) in Interest Payments in 2006 to that in 2010?
Keep it short and to the point. 0.99. What is the ratio of the Expenses (in $) of Other expenses in 2006 to that in 2010?
Your response must be concise. 0.75. What is the ratio of the Expenses (in $) in Salary of employees in 2006 to that in 2011?
Your answer should be very brief. 1.03. What is the ratio of the Expenses (in $) in Custom duties in 2006 to that in 2011?
Offer a very short reply. 1.43. What is the ratio of the Expenses (in $) in Interest Payments in 2006 to that in 2011?
Ensure brevity in your answer.  0.9. What is the ratio of the Expenses (in $) of Other expenses in 2006 to that in 2011?
Your response must be concise. 0.74. What is the ratio of the Expenses (in $) of Salary of employees in 2006 to that in 2012?
Provide a succinct answer. 1.05. What is the ratio of the Expenses (in $) of Custom duties in 2006 to that in 2012?
Your answer should be very brief. 1.33. What is the ratio of the Expenses (in $) in Interest Payments in 2006 to that in 2012?
Your answer should be compact. 0.74. What is the ratio of the Expenses (in $) of Other expenses in 2006 to that in 2012?
Provide a short and direct response. 0.72. What is the ratio of the Expenses (in $) in Salary of employees in 2007 to that in 2008?
Make the answer very short. 1.28. What is the ratio of the Expenses (in $) of Custom duties in 2007 to that in 2008?
Provide a succinct answer. 0.81. What is the ratio of the Expenses (in $) in Interest Payments in 2007 to that in 2008?
Your answer should be compact. 1.1. What is the ratio of the Expenses (in $) in Other expenses in 2007 to that in 2008?
Make the answer very short. 0.86. What is the ratio of the Expenses (in $) in Salary of employees in 2007 to that in 2009?
Offer a terse response. 1.17. What is the ratio of the Expenses (in $) of Interest Payments in 2007 to that in 2009?
Provide a short and direct response. 1.19. What is the ratio of the Expenses (in $) of Other expenses in 2007 to that in 2009?
Your answer should be very brief. 0.84. What is the ratio of the Expenses (in $) in Salary of employees in 2007 to that in 2010?
Your answer should be very brief. 1.17. What is the ratio of the Expenses (in $) of Custom duties in 2007 to that in 2010?
Keep it short and to the point. 1.08. What is the ratio of the Expenses (in $) of Interest Payments in 2007 to that in 2010?
Your response must be concise. 0.92. What is the ratio of the Expenses (in $) of Other expenses in 2007 to that in 2010?
Offer a very short reply. 0.83. What is the ratio of the Expenses (in $) of Salary of employees in 2007 to that in 2011?
Your answer should be very brief. 1.15. What is the ratio of the Expenses (in $) in Custom duties in 2007 to that in 2011?
Your response must be concise. 1.35. What is the ratio of the Expenses (in $) in Interest Payments in 2007 to that in 2011?
Your response must be concise. 0.84. What is the ratio of the Expenses (in $) of Other expenses in 2007 to that in 2011?
Give a very brief answer. 0.81. What is the ratio of the Expenses (in $) in Salary of employees in 2007 to that in 2012?
Your answer should be compact. 1.17. What is the ratio of the Expenses (in $) of Custom duties in 2007 to that in 2012?
Offer a terse response. 1.25. What is the ratio of the Expenses (in $) of Interest Payments in 2007 to that in 2012?
Ensure brevity in your answer.  0.69. What is the ratio of the Expenses (in $) in Other expenses in 2007 to that in 2012?
Provide a succinct answer. 0.8. What is the ratio of the Expenses (in $) in Salary of employees in 2008 to that in 2009?
Your answer should be compact. 0.92. What is the ratio of the Expenses (in $) in Interest Payments in 2008 to that in 2009?
Your answer should be very brief. 1.08. What is the ratio of the Expenses (in $) of Other expenses in 2008 to that in 2009?
Make the answer very short. 0.98. What is the ratio of the Expenses (in $) in Salary of employees in 2008 to that in 2010?
Give a very brief answer. 0.92. What is the ratio of the Expenses (in $) of Custom duties in 2008 to that in 2010?
Offer a very short reply. 1.33. What is the ratio of the Expenses (in $) of Interest Payments in 2008 to that in 2010?
Make the answer very short. 0.83. What is the ratio of the Expenses (in $) in Other expenses in 2008 to that in 2010?
Make the answer very short. 0.96. What is the ratio of the Expenses (in $) of Salary of employees in 2008 to that in 2011?
Make the answer very short. 0.9. What is the ratio of the Expenses (in $) of Custom duties in 2008 to that in 2011?
Offer a terse response. 1.66. What is the ratio of the Expenses (in $) in Interest Payments in 2008 to that in 2011?
Offer a very short reply. 0.76. What is the ratio of the Expenses (in $) in Other expenses in 2008 to that in 2011?
Keep it short and to the point. 0.94. What is the ratio of the Expenses (in $) of Salary of employees in 2008 to that in 2012?
Ensure brevity in your answer.  0.92. What is the ratio of the Expenses (in $) of Custom duties in 2008 to that in 2012?
Ensure brevity in your answer.  1.54. What is the ratio of the Expenses (in $) of Interest Payments in 2008 to that in 2012?
Offer a terse response. 0.63. What is the ratio of the Expenses (in $) of Other expenses in 2008 to that in 2012?
Keep it short and to the point. 0.92. What is the ratio of the Expenses (in $) of Salary of employees in 2009 to that in 2010?
Your answer should be compact. 1. What is the ratio of the Expenses (in $) of Custom duties in 2009 to that in 2010?
Offer a very short reply. 1.11. What is the ratio of the Expenses (in $) of Interest Payments in 2009 to that in 2010?
Provide a succinct answer. 0.77. What is the ratio of the Expenses (in $) in Other expenses in 2009 to that in 2010?
Offer a terse response. 0.99. What is the ratio of the Expenses (in $) of Salary of employees in 2009 to that in 2011?
Ensure brevity in your answer.  0.98. What is the ratio of the Expenses (in $) of Custom duties in 2009 to that in 2011?
Provide a succinct answer. 1.38. What is the ratio of the Expenses (in $) in Interest Payments in 2009 to that in 2011?
Your answer should be compact. 0.7. What is the ratio of the Expenses (in $) in Other expenses in 2009 to that in 2011?
Keep it short and to the point. 0.97. What is the ratio of the Expenses (in $) of Interest Payments in 2009 to that in 2012?
Your response must be concise. 0.58. What is the ratio of the Expenses (in $) of Other expenses in 2009 to that in 2012?
Your response must be concise. 0.95. What is the ratio of the Expenses (in $) in Salary of employees in 2010 to that in 2011?
Provide a short and direct response. 0.98. What is the ratio of the Expenses (in $) in Custom duties in 2010 to that in 2011?
Offer a very short reply. 1.25. What is the ratio of the Expenses (in $) in Interest Payments in 2010 to that in 2011?
Keep it short and to the point. 0.91. What is the ratio of the Expenses (in $) in Salary of employees in 2010 to that in 2012?
Provide a succinct answer. 1. What is the ratio of the Expenses (in $) of Custom duties in 2010 to that in 2012?
Your answer should be very brief. 1.16. What is the ratio of the Expenses (in $) of Interest Payments in 2010 to that in 2012?
Give a very brief answer. 0.75. What is the ratio of the Expenses (in $) of Other expenses in 2010 to that in 2012?
Ensure brevity in your answer.  0.96. What is the ratio of the Expenses (in $) in Salary of employees in 2011 to that in 2012?
Ensure brevity in your answer.  1.02. What is the ratio of the Expenses (in $) of Custom duties in 2011 to that in 2012?
Give a very brief answer. 0.93. What is the ratio of the Expenses (in $) in Interest Payments in 2011 to that in 2012?
Your answer should be compact. 0.82. What is the ratio of the Expenses (in $) in Other expenses in 2011 to that in 2012?
Offer a very short reply. 0.98. What is the difference between the highest and the second highest Expenses (in $) in Salary of employees?
Your answer should be very brief. 2.67e+09. What is the difference between the highest and the second highest Expenses (in $) in Custom duties?
Ensure brevity in your answer.  8.78e+08. What is the difference between the highest and the second highest Expenses (in $) in Interest Payments?
Your answer should be very brief. 7.45e+08. What is the difference between the highest and the second highest Expenses (in $) of Other expenses?
Keep it short and to the point. 2.55e+09. What is the difference between the highest and the lowest Expenses (in $) of Salary of employees?
Offer a very short reply. 5.76e+09. What is the difference between the highest and the lowest Expenses (in $) in Custom duties?
Give a very brief answer. 2.50e+09. What is the difference between the highest and the lowest Expenses (in $) of Interest Payments?
Your answer should be compact. 1.77e+09. What is the difference between the highest and the lowest Expenses (in $) of Other expenses?
Offer a terse response. 3.81e+1. 